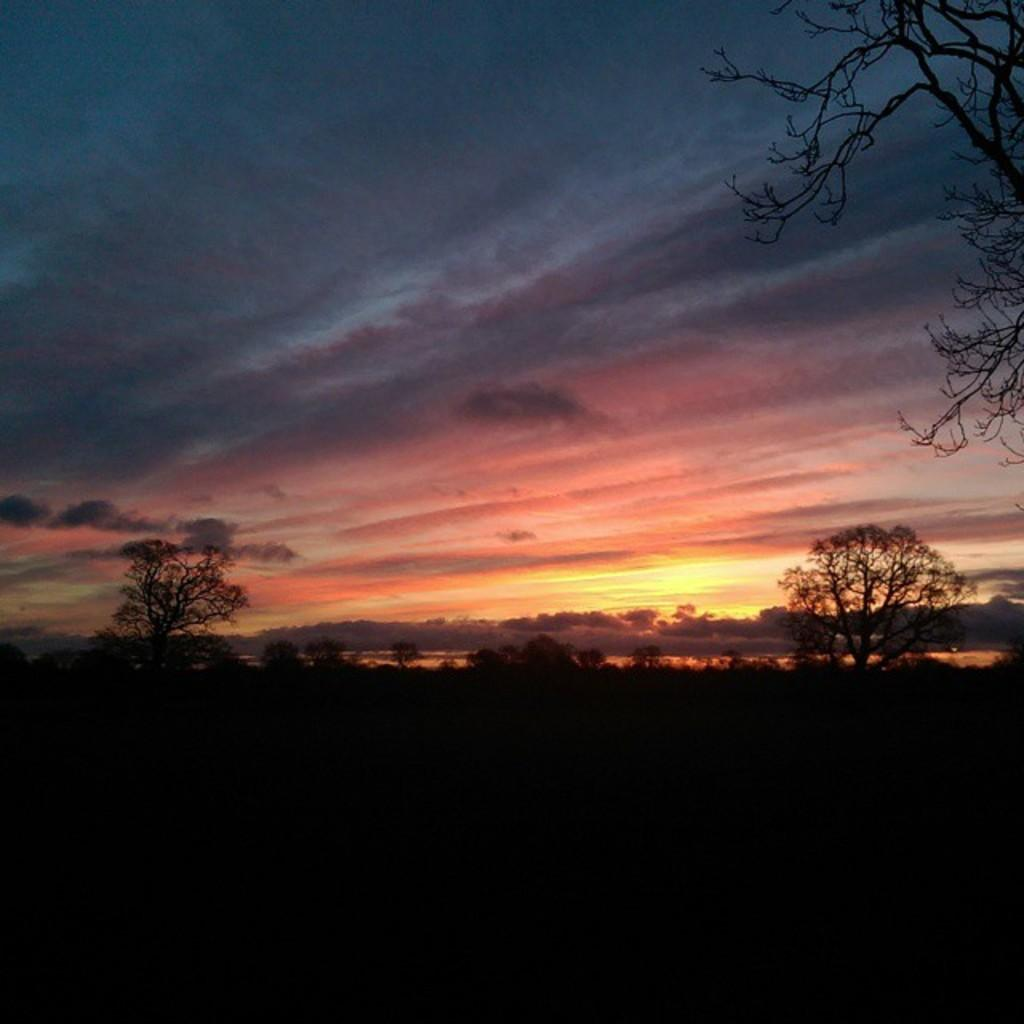What type of scene is shown in the image? The image depicts a beautiful view of nature. Can you describe any specific features of the landscape? There are dry trees in the image. What body of water can be seen in the image? There is a small water pond in the image. How would you describe the sky in the image? The sky in the image has a red color sunset. Where is the creator of the image located in the picture? There is no creator present in the image; it is a photograph or illustration of a natural scene. Can you see any holes in the image? There are no holes visible in the image; it is a complete and intact representation of a natural scene. 